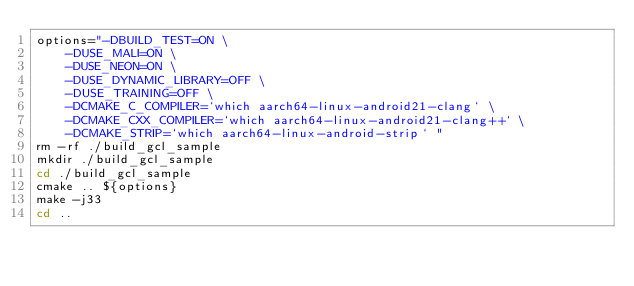<code> <loc_0><loc_0><loc_500><loc_500><_Bash_>options="-DBUILD_TEST=ON \
    -DUSE_MALI=ON \
    -DUSE_NEON=ON \
    -DUSE_DYNAMIC_LIBRARY=OFF \
    -DUSE_TRAINING=OFF \
    -DCMAKE_C_COMPILER=`which aarch64-linux-android21-clang` \
    -DCMAKE_CXX_COMPILER=`which aarch64-linux-android21-clang++` \
    -DCMAKE_STRIP=`which aarch64-linux-android-strip` "
rm -rf ./build_gcl_sample
mkdir ./build_gcl_sample
cd ./build_gcl_sample
cmake .. ${options}
make -j33
cd ..
</code> 